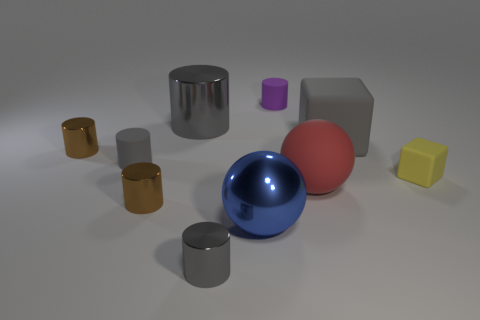Subtract all red balls. How many gray cylinders are left? 3 Subtract all brown cylinders. How many cylinders are left? 4 Subtract all matte cylinders. How many cylinders are left? 4 Subtract all green cylinders. Subtract all cyan balls. How many cylinders are left? 6 Subtract all balls. How many objects are left? 8 Add 2 blue spheres. How many blue spheres are left? 3 Add 7 big gray shiny things. How many big gray shiny things exist? 8 Subtract 0 cyan balls. How many objects are left? 10 Subtract all tiny blocks. Subtract all large rubber things. How many objects are left? 7 